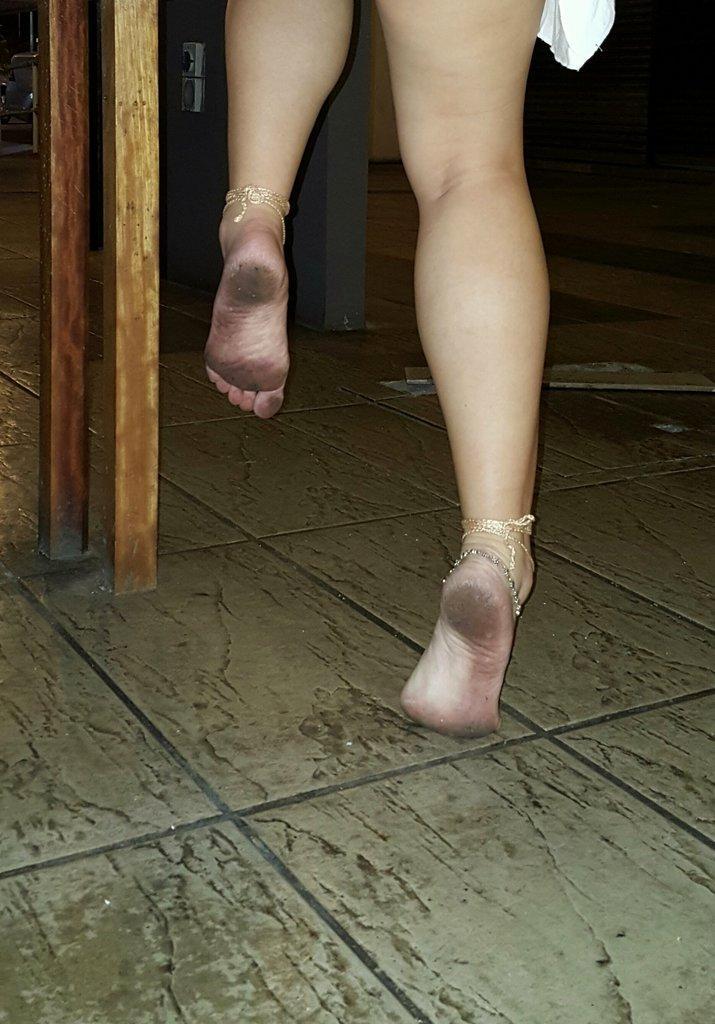Please provide a concise description of this image. In this image we can see the woman legs with anklets. We can also see the wooden poles on the surface. 